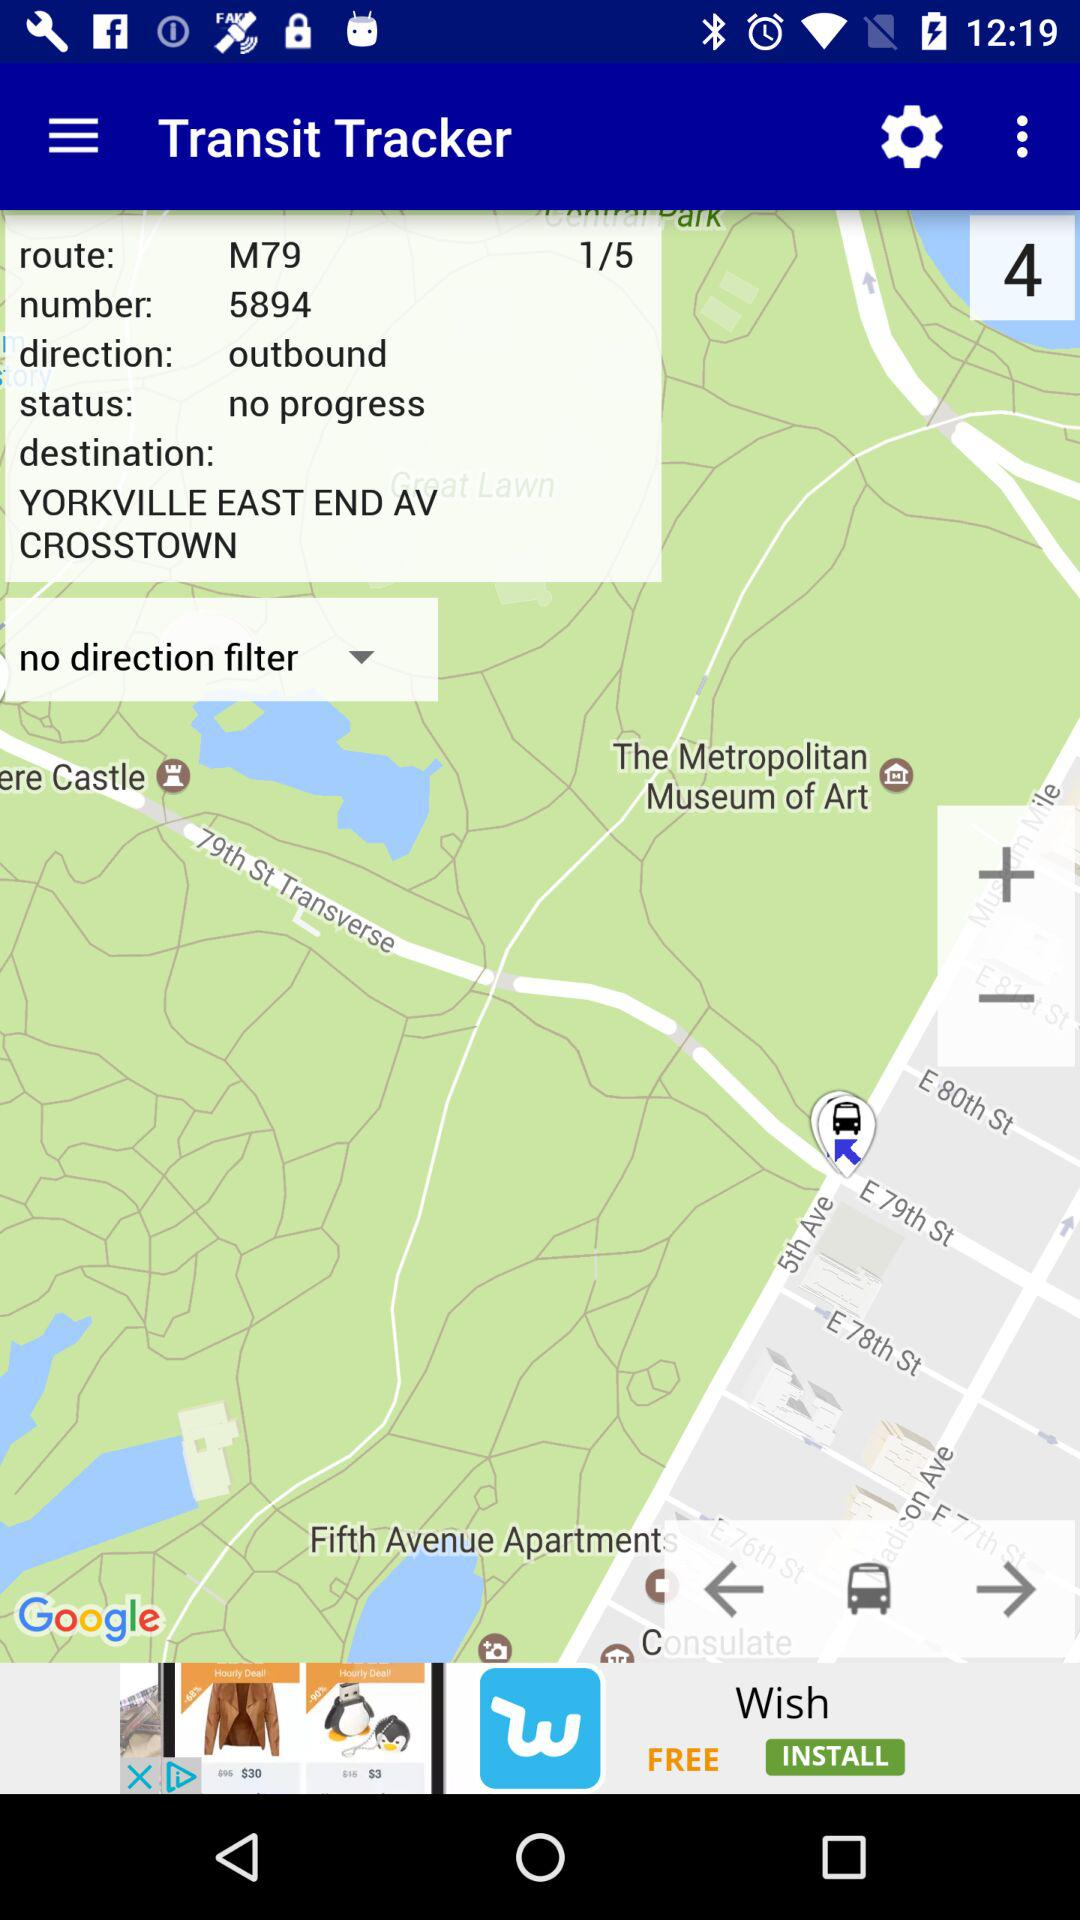What is the number? The number is 5894. 